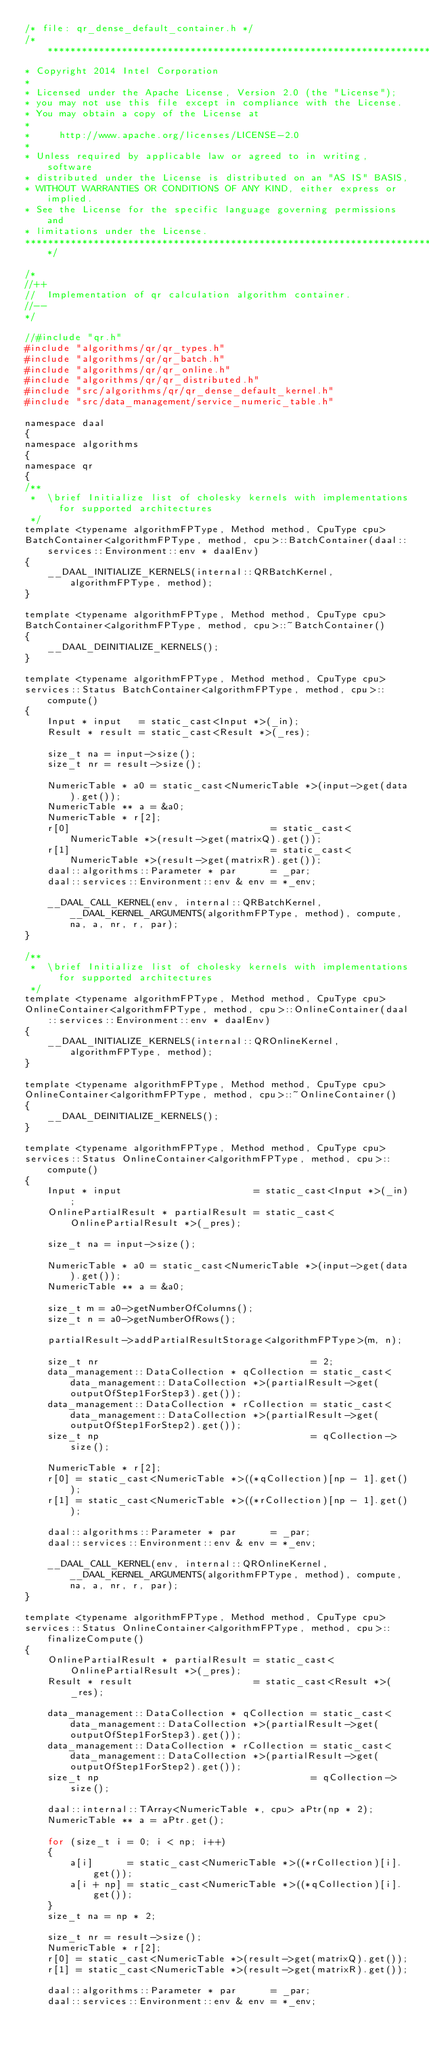Convert code to text. <code><loc_0><loc_0><loc_500><loc_500><_C_>/* file: qr_dense_default_container.h */
/*******************************************************************************
* Copyright 2014 Intel Corporation
*
* Licensed under the Apache License, Version 2.0 (the "License");
* you may not use this file except in compliance with the License.
* You may obtain a copy of the License at
*
*     http://www.apache.org/licenses/LICENSE-2.0
*
* Unless required by applicable law or agreed to in writing, software
* distributed under the License is distributed on an "AS IS" BASIS,
* WITHOUT WARRANTIES OR CONDITIONS OF ANY KIND, either express or implied.
* See the License for the specific language governing permissions and
* limitations under the License.
*******************************************************************************/

/*
//++
//  Implementation of qr calculation algorithm container.
//--
*/

//#include "qr.h"
#include "algorithms/qr/qr_types.h"
#include "algorithms/qr/qr_batch.h"
#include "algorithms/qr/qr_online.h"
#include "algorithms/qr/qr_distributed.h"
#include "src/algorithms/qr/qr_dense_default_kernel.h"
#include "src/data_management/service_numeric_table.h"

namespace daal
{
namespace algorithms
{
namespace qr
{
/**
 *  \brief Initialize list of cholesky kernels with implementations for supported architectures
 */
template <typename algorithmFPType, Method method, CpuType cpu>
BatchContainer<algorithmFPType, method, cpu>::BatchContainer(daal::services::Environment::env * daalEnv)
{
    __DAAL_INITIALIZE_KERNELS(internal::QRBatchKernel, algorithmFPType, method);
}

template <typename algorithmFPType, Method method, CpuType cpu>
BatchContainer<algorithmFPType, method, cpu>::~BatchContainer()
{
    __DAAL_DEINITIALIZE_KERNELS();
}

template <typename algorithmFPType, Method method, CpuType cpu>
services::Status BatchContainer<algorithmFPType, method, cpu>::compute()
{
    Input * input   = static_cast<Input *>(_in);
    Result * result = static_cast<Result *>(_res);

    size_t na = input->size();
    size_t nr = result->size();

    NumericTable * a0 = static_cast<NumericTable *>(input->get(data).get());
    NumericTable ** a = &a0;
    NumericTable * r[2];
    r[0]                                   = static_cast<NumericTable *>(result->get(matrixQ).get());
    r[1]                                   = static_cast<NumericTable *>(result->get(matrixR).get());
    daal::algorithms::Parameter * par      = _par;
    daal::services::Environment::env & env = *_env;

    __DAAL_CALL_KERNEL(env, internal::QRBatchKernel, __DAAL_KERNEL_ARGUMENTS(algorithmFPType, method), compute, na, a, nr, r, par);
}

/**
 *  \brief Initialize list of cholesky kernels with implementations for supported architectures
 */
template <typename algorithmFPType, Method method, CpuType cpu>
OnlineContainer<algorithmFPType, method, cpu>::OnlineContainer(daal::services::Environment::env * daalEnv)
{
    __DAAL_INITIALIZE_KERNELS(internal::QROnlineKernel, algorithmFPType, method);
}

template <typename algorithmFPType, Method method, CpuType cpu>
OnlineContainer<algorithmFPType, method, cpu>::~OnlineContainer()
{
    __DAAL_DEINITIALIZE_KERNELS();
}

template <typename algorithmFPType, Method method, CpuType cpu>
services::Status OnlineContainer<algorithmFPType, method, cpu>::compute()
{
    Input * input                       = static_cast<Input *>(_in);
    OnlinePartialResult * partialResult = static_cast<OnlinePartialResult *>(_pres);

    size_t na = input->size();

    NumericTable * a0 = static_cast<NumericTable *>(input->get(data).get());
    NumericTable ** a = &a0;

    size_t m = a0->getNumberOfColumns();
    size_t n = a0->getNumberOfRows();

    partialResult->addPartialResultStorage<algorithmFPType>(m, n);

    size_t nr                                     = 2;
    data_management::DataCollection * qCollection = static_cast<data_management::DataCollection *>(partialResult->get(outputOfStep1ForStep3).get());
    data_management::DataCollection * rCollection = static_cast<data_management::DataCollection *>(partialResult->get(outputOfStep1ForStep2).get());
    size_t np                                     = qCollection->size();

    NumericTable * r[2];
    r[0] = static_cast<NumericTable *>((*qCollection)[np - 1].get());
    r[1] = static_cast<NumericTable *>((*rCollection)[np - 1].get());

    daal::algorithms::Parameter * par      = _par;
    daal::services::Environment::env & env = *_env;

    __DAAL_CALL_KERNEL(env, internal::QROnlineKernel, __DAAL_KERNEL_ARGUMENTS(algorithmFPType, method), compute, na, a, nr, r, par);
}

template <typename algorithmFPType, Method method, CpuType cpu>
services::Status OnlineContainer<algorithmFPType, method, cpu>::finalizeCompute()
{
    OnlinePartialResult * partialResult = static_cast<OnlinePartialResult *>(_pres);
    Result * result                     = static_cast<Result *>(_res);

    data_management::DataCollection * qCollection = static_cast<data_management::DataCollection *>(partialResult->get(outputOfStep1ForStep3).get());
    data_management::DataCollection * rCollection = static_cast<data_management::DataCollection *>(partialResult->get(outputOfStep1ForStep2).get());
    size_t np                                     = qCollection->size();

    daal::internal::TArray<NumericTable *, cpu> aPtr(np * 2);
    NumericTable ** a = aPtr.get();

    for (size_t i = 0; i < np; i++)
    {
        a[i]      = static_cast<NumericTable *>((*rCollection)[i].get());
        a[i + np] = static_cast<NumericTable *>((*qCollection)[i].get());
    }
    size_t na = np * 2;

    size_t nr = result->size();
    NumericTable * r[2];
    r[0] = static_cast<NumericTable *>(result->get(matrixQ).get());
    r[1] = static_cast<NumericTable *>(result->get(matrixR).get());

    daal::algorithms::Parameter * par      = _par;
    daal::services::Environment::env & env = *_env;
</code> 